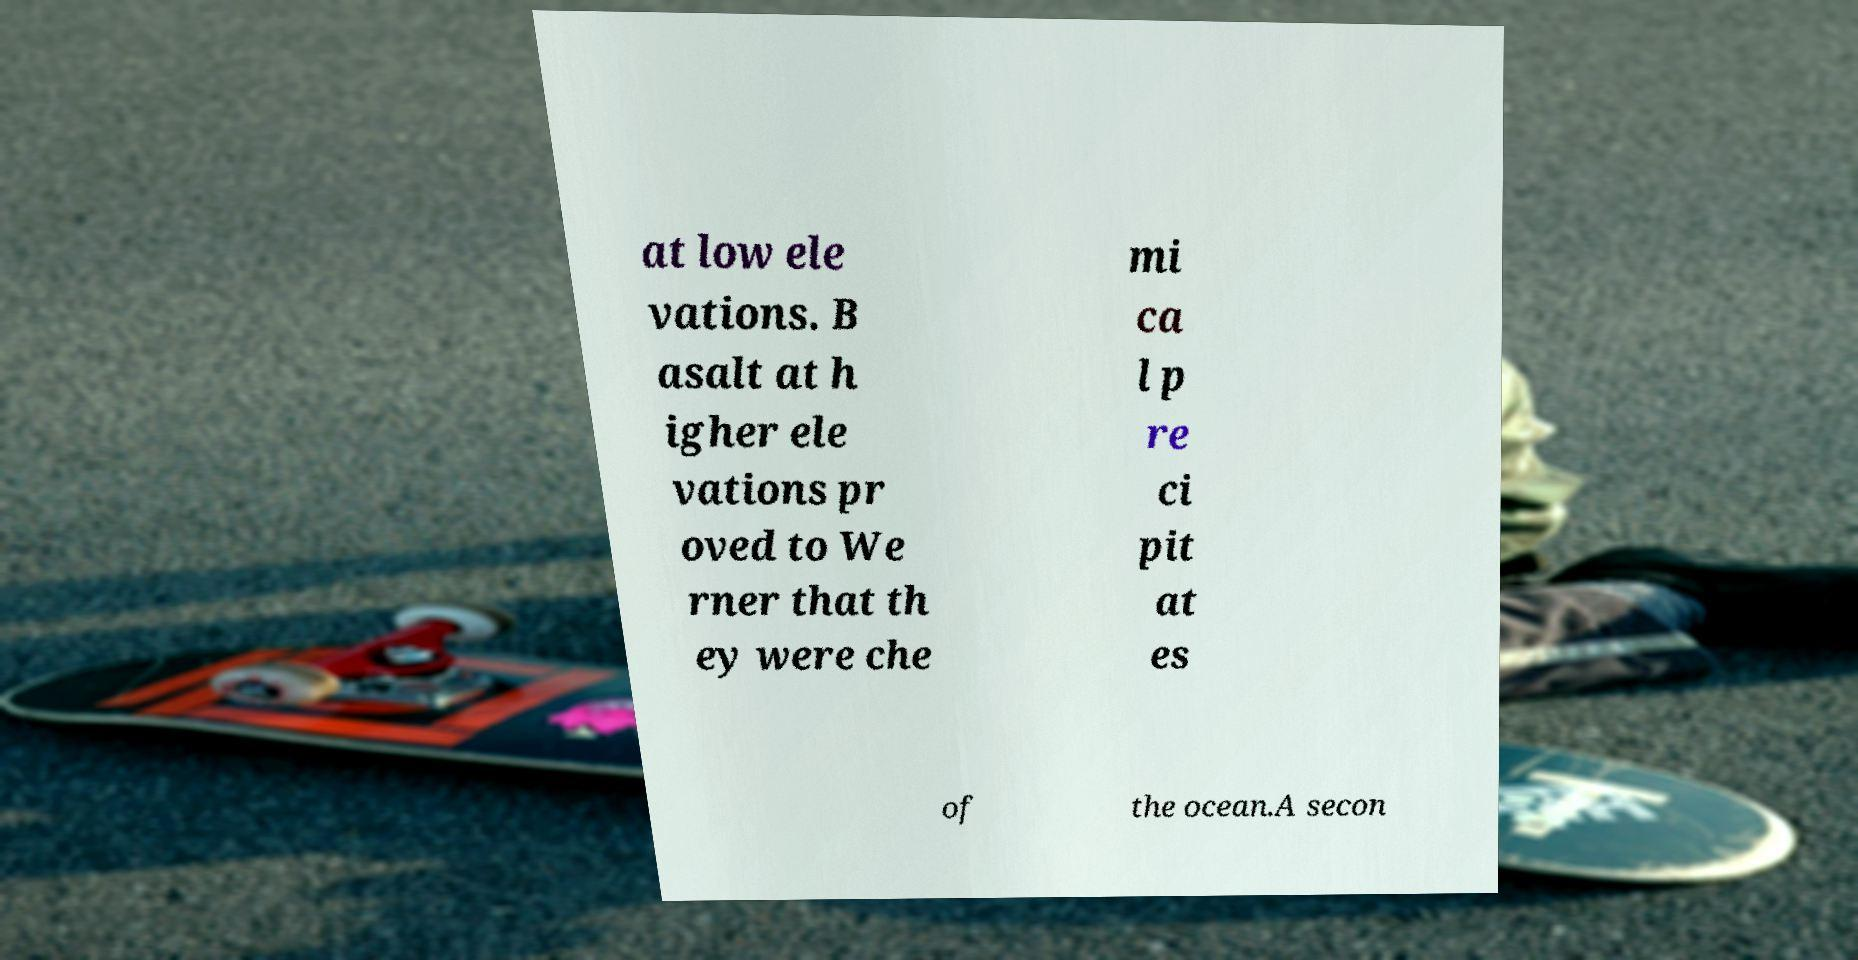Can you read and provide the text displayed in the image?This photo seems to have some interesting text. Can you extract and type it out for me? at low ele vations. B asalt at h igher ele vations pr oved to We rner that th ey were che mi ca l p re ci pit at es of the ocean.A secon 